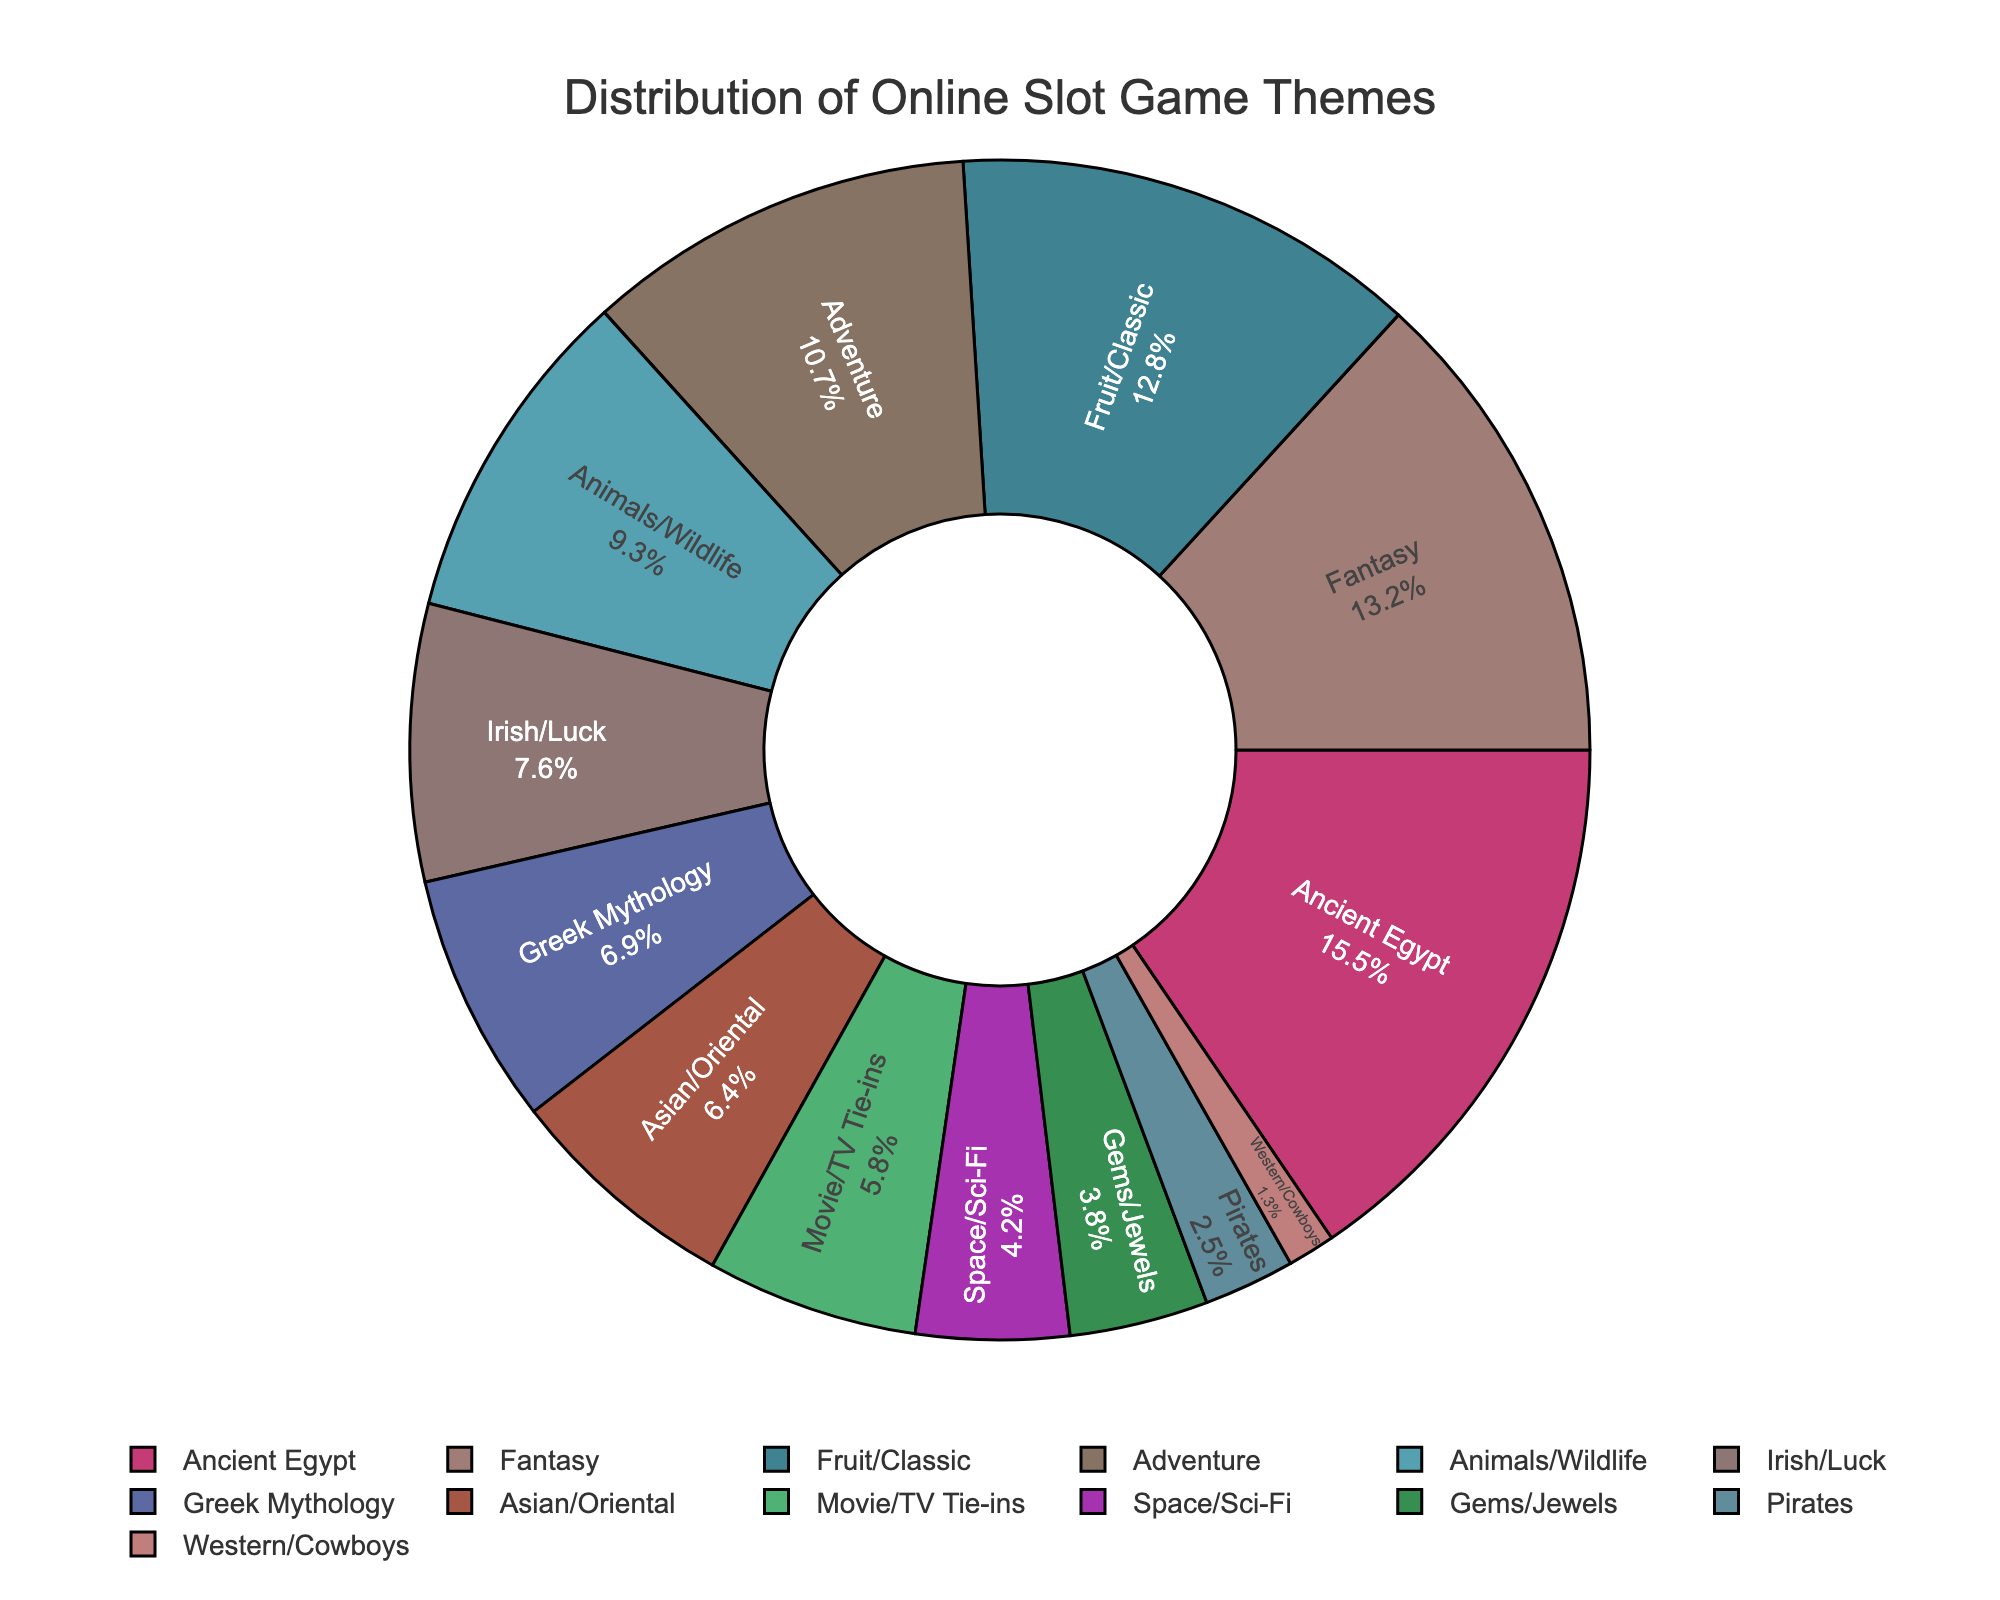Which theme has the largest percentage? The Ancient Egypt theme has the largest percentage as observed from the pie chart segment with the highest value.
Answer: Ancient Egypt How much larger is the percentage for Ancient Egypt compared to Fantasy? The percentage for Ancient Egypt is 15.5%, and for Fantasy, it's 13.2%. The difference is 15.5 - 13.2 = 2.3%.
Answer: 2.3% What is the combined percentage of Fruit/Classic and Adventure themes? The percentage for Fruit/Classic is 12.8% and for Adventure is 10.7%. Sum these values to find the combined percentage: 12.8 + 10.7 = 23.5%.
Answer: 23.5% Which theme is represented by the smallest slice in the pie chart? The Western/Cowboys theme has the smallest percentage at 1.3%.
Answer: Western/Cowboys Are there more themes with a percentage higher than 10% or lower than 10%? Count the themes with percentages higher than 10%: Ancient Egypt, Fantasy, Fruit/Classic, Adventure (4 themes). Count the themes lower than 10%: Animals/Wildlife, Irish/Luck, Greek Mythology, Asian/Oriental, Movie/TV Tie-ins, Space/Sci-Fi, Gems/Jewels, Pirates, Western/Cowboys (9 themes). There are more themes with a lower percentage.
Answer: Lower than 10% By what percentage does the Ancient Egypt theme exceed the Space/Sci-Fi theme? The percentage for Ancient Egypt is 15.5% and for Space/Sci-Fi is 4.2%. Calculate the difference: 15.5 - 4.2 = 11.3%.
Answer: 11.3% What is the total percentage covered by themes related to myths (Ancient Egypt, Greek Mythology)? The percentage for Ancient Egypt is 15.5% and for Greek Mythology is 6.9%. Sum these values to find the total percentage: 15.5 + 6.9 = 22.4%.
Answer: 22.4% Which theme is represented by the color closest to blue and what is its percentage? Since specific color values aren't given, checking the pie chart visually for the theme with the bluest color closest to blue, suppose it's the Fantasy theme, at 13.2%.
Answer: Fantasy, 13.2% 